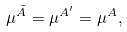Convert formula to latex. <formula><loc_0><loc_0><loc_500><loc_500>\mu ^ { \tilde { A } } = \mu ^ { A ^ { \prime } } = \mu ^ { A } ,</formula> 